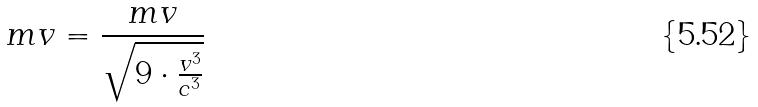<formula> <loc_0><loc_0><loc_500><loc_500>m v = \frac { m v } { \sqrt { 9 \cdot \frac { v ^ { 3 } } { c ^ { 3 } } } }</formula> 